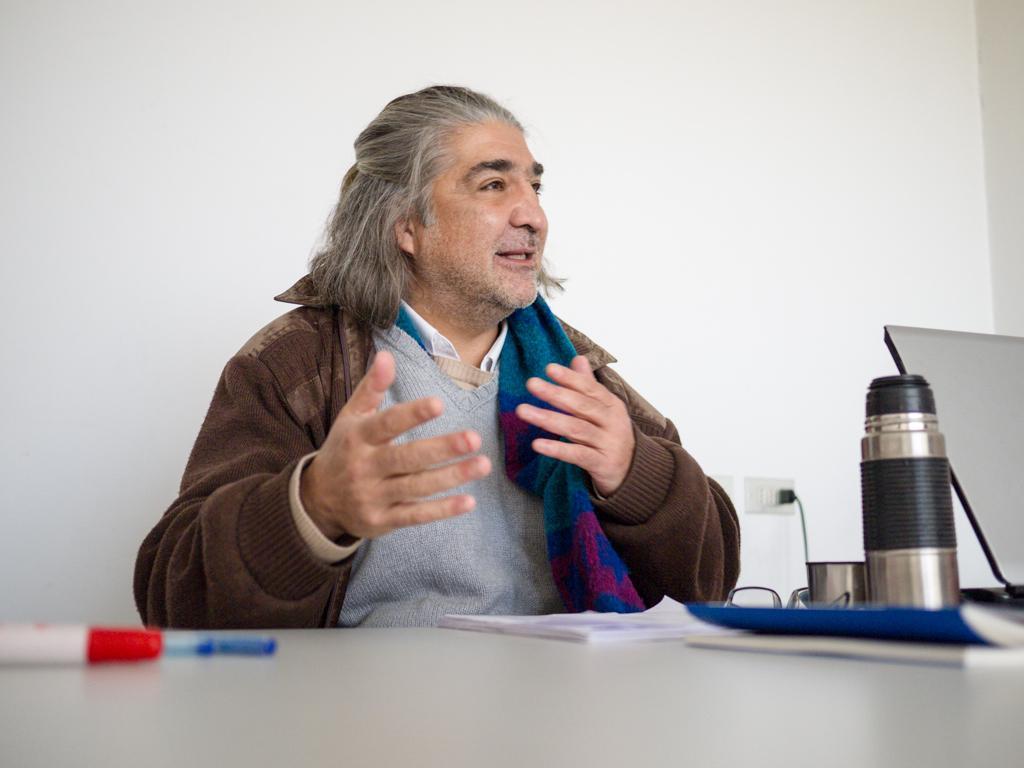In one or two sentences, can you explain what this image depicts? There is a person wearing a jacket and sitting. In front of him there is a table. On the table there are pens, books, bottles, specs, papers and a laptop. In the background there is a wall. On the wall there is a socket with plug. 